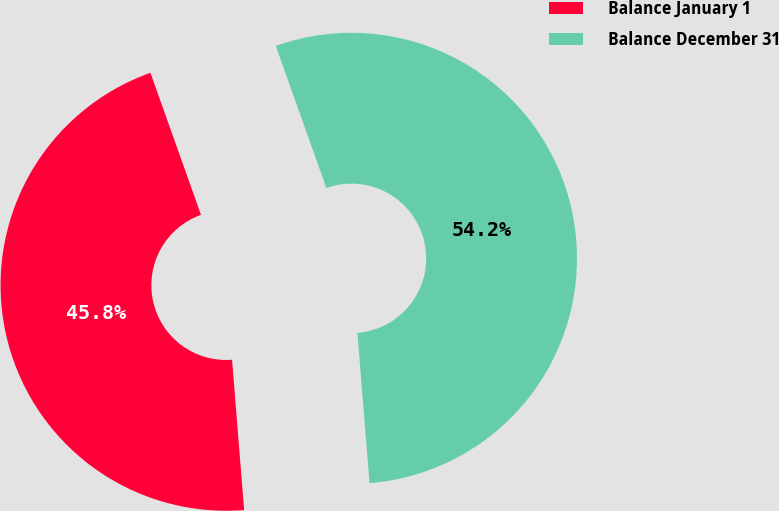Convert chart to OTSL. <chart><loc_0><loc_0><loc_500><loc_500><pie_chart><fcel>Balance January 1<fcel>Balance December 31<nl><fcel>45.83%<fcel>54.17%<nl></chart> 